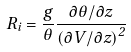Convert formula to latex. <formula><loc_0><loc_0><loc_500><loc_500>R _ { i } = \frac { g } { \theta } \frac { \partial \theta / \partial z } { \left ( \partial V / \partial z \right ) ^ { 2 } }</formula> 